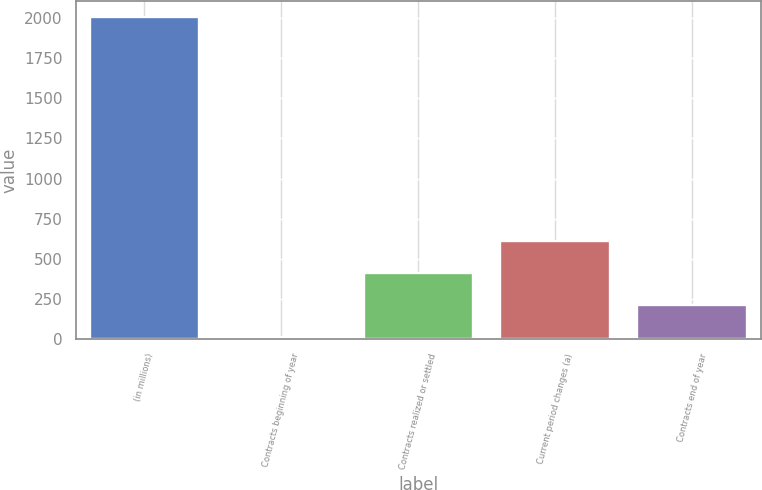Convert chart. <chart><loc_0><loc_0><loc_500><loc_500><bar_chart><fcel>(in millions)<fcel>Contracts beginning of year<fcel>Contracts realized or settled<fcel>Current period changes (a)<fcel>Contracts end of year<nl><fcel>2005<fcel>11<fcel>409.8<fcel>609.2<fcel>210.4<nl></chart> 